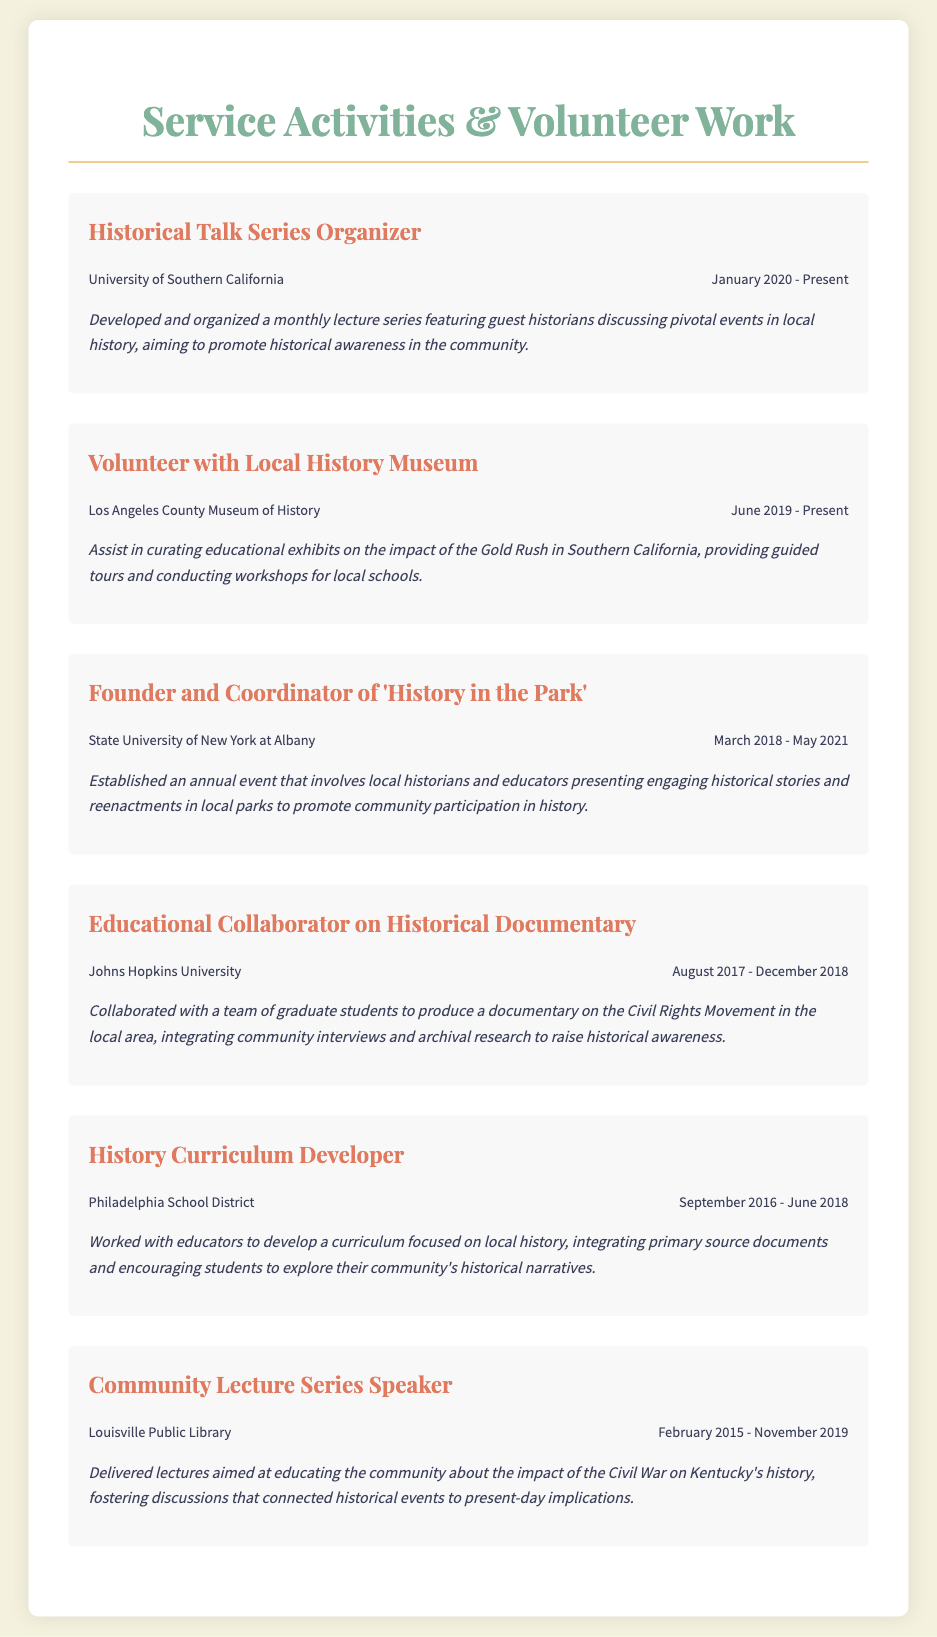What is the title of the resume? The title of the document is prominently displayed at the top, indicating the content of the resume.
Answer: Service Activities & Volunteer Work Who organized the Historical Talk Series? The activity details the role of organizing a lecture series, identifying the individual or group responsible.
Answer: Historical Talk Series Organizer When did the founder of 'History in the Park' serve? This is asked to understand the time frame of the activity mentioned in the resume.
Answer: March 2018 - May 2021 What museum does the volunteer work pertain to? The document specifies the location where volunteer work is performed, highlighting the institution involved.
Answer: Los Angeles County Museum of History What was the focus of the curriculum developed for the Philadelphia School District? This explores the theme of the curriculum, showcasing its educational scope.
Answer: Local history What annual event did the founder of 'History in the Park' establish? This relates to the specific initiative mentioned in the resume, capturing the essence of community engagement.
Answer: History in the Park How long did the Community Lecture Series Speaker's roles span? This question seeks to quantify the duration of an activity representing a community outreach effort.
Answer: February 2015 - November 2019 What was the primary topic of the lectures delivered at the Community Lecture Series? This question targets the main subject matter discussed in the lectures, reflecting on the educational focus.
Answer: Impact of the Civil War on Kentucky's history 